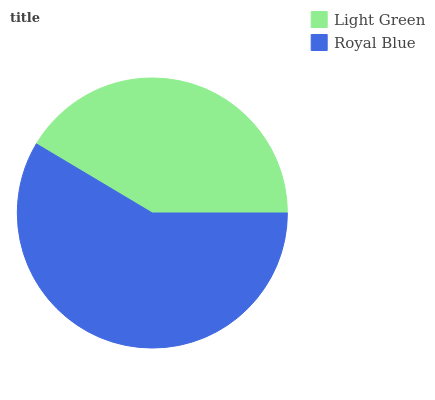Is Light Green the minimum?
Answer yes or no. Yes. Is Royal Blue the maximum?
Answer yes or no. Yes. Is Royal Blue the minimum?
Answer yes or no. No. Is Royal Blue greater than Light Green?
Answer yes or no. Yes. Is Light Green less than Royal Blue?
Answer yes or no. Yes. Is Light Green greater than Royal Blue?
Answer yes or no. No. Is Royal Blue less than Light Green?
Answer yes or no. No. Is Royal Blue the high median?
Answer yes or no. Yes. Is Light Green the low median?
Answer yes or no. Yes. Is Light Green the high median?
Answer yes or no. No. Is Royal Blue the low median?
Answer yes or no. No. 